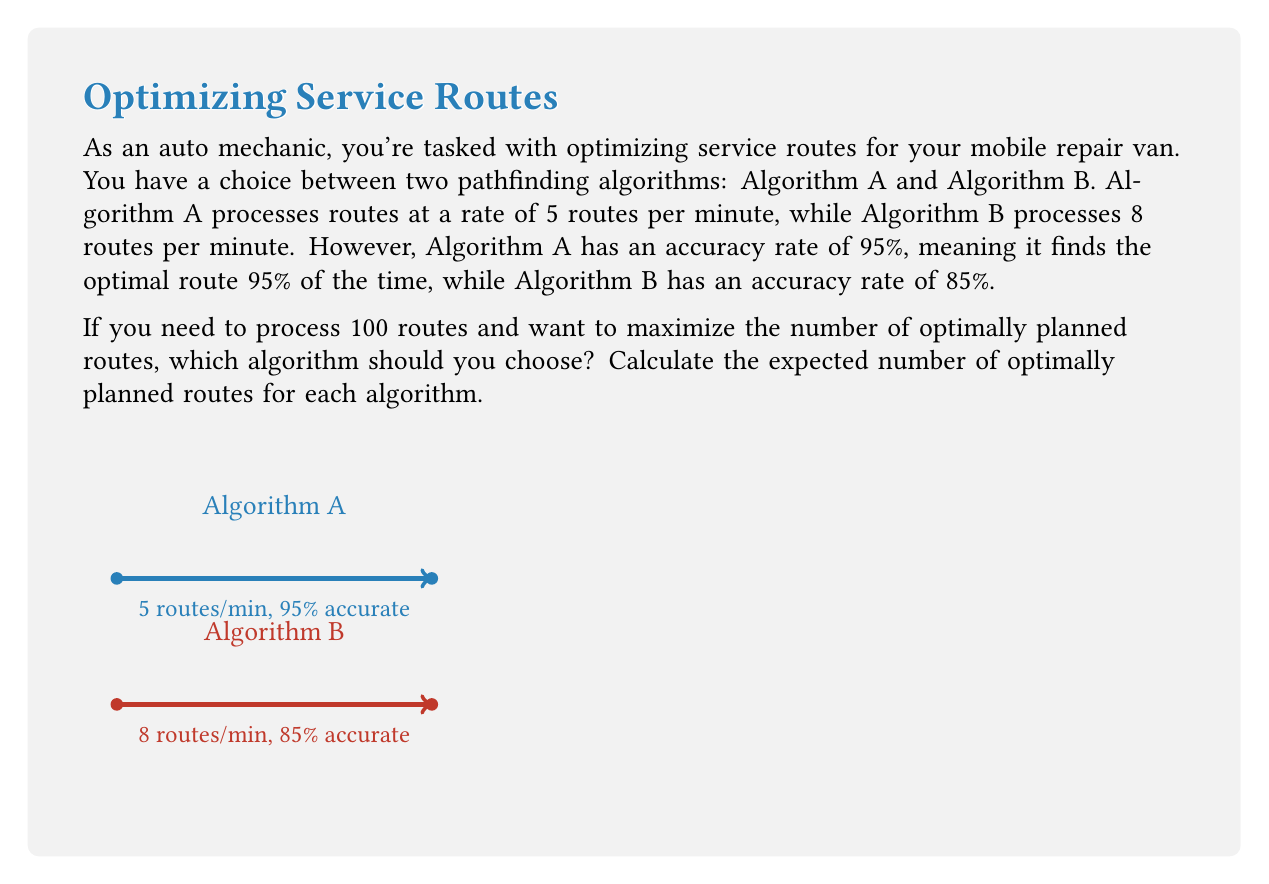Solve this math problem. Let's approach this step-by-step:

1) First, let's calculate the expected number of optimally planned routes for Algorithm A:
   - Total routes to process: 100
   - Accuracy rate: 95% = 0.95
   - Expected optimal routes: $100 \times 0.95 = 95$

2) Now, let's calculate the same for Algorithm B:
   - Total routes to process: 100
   - Accuracy rate: 85% = 0.85
   - Expected optimal routes: $100 \times 0.85 = 85$

3) We can see that Algorithm A is expected to produce more optimally planned routes (95) compared to Algorithm B (85).

4) To further illustrate the difference, we can calculate the processing time for each algorithm:
   - Algorithm A: $100 \div 5 = 20$ minutes
   - Algorithm B: $100 \div 8 = 12.5$ minutes

5) Even though Algorithm B is faster, it produces fewer optimal routes in this case.

The efficiency of an algorithm in this context can be defined as:

$$\text{Efficiency} = \frac{\text{Number of optimal routes}}{\text{Total routes}} \times 100\%$$

For Algorithm A: $\text{Efficiency}_A = \frac{95}{100} \times 100\% = 95\%$
For Algorithm B: $\text{Efficiency}_B = \frac{85}{100} \times 100\% = 85\%$

Therefore, Algorithm A is more efficient for this specific task, despite being slower.
Answer: Algorithm A, with 95 expected optimal routes. 